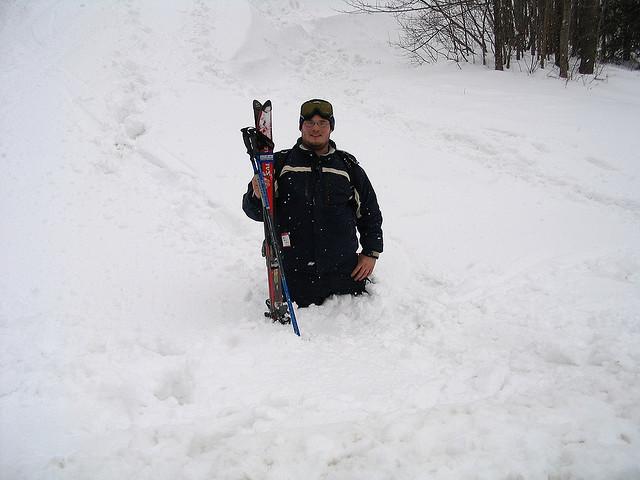Is this in a snow storm?
Keep it brief. No. Is this person wearing gloves?
Give a very brief answer. No. Is the man eating something?
Quick response, please. No. Are the front tips of the man's skis in the snow?
Short answer required. Yes. What is the color of this person's ski suit?
Keep it brief. Black. Could this be on the equator?
Write a very short answer. No. How high is the snow?
Be succinct. 3 feet. What is on the person's hands?
Concise answer only. Skis. 